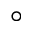Convert formula to latex. <formula><loc_0><loc_0><loc_500><loc_500>^ { \circ }</formula> 